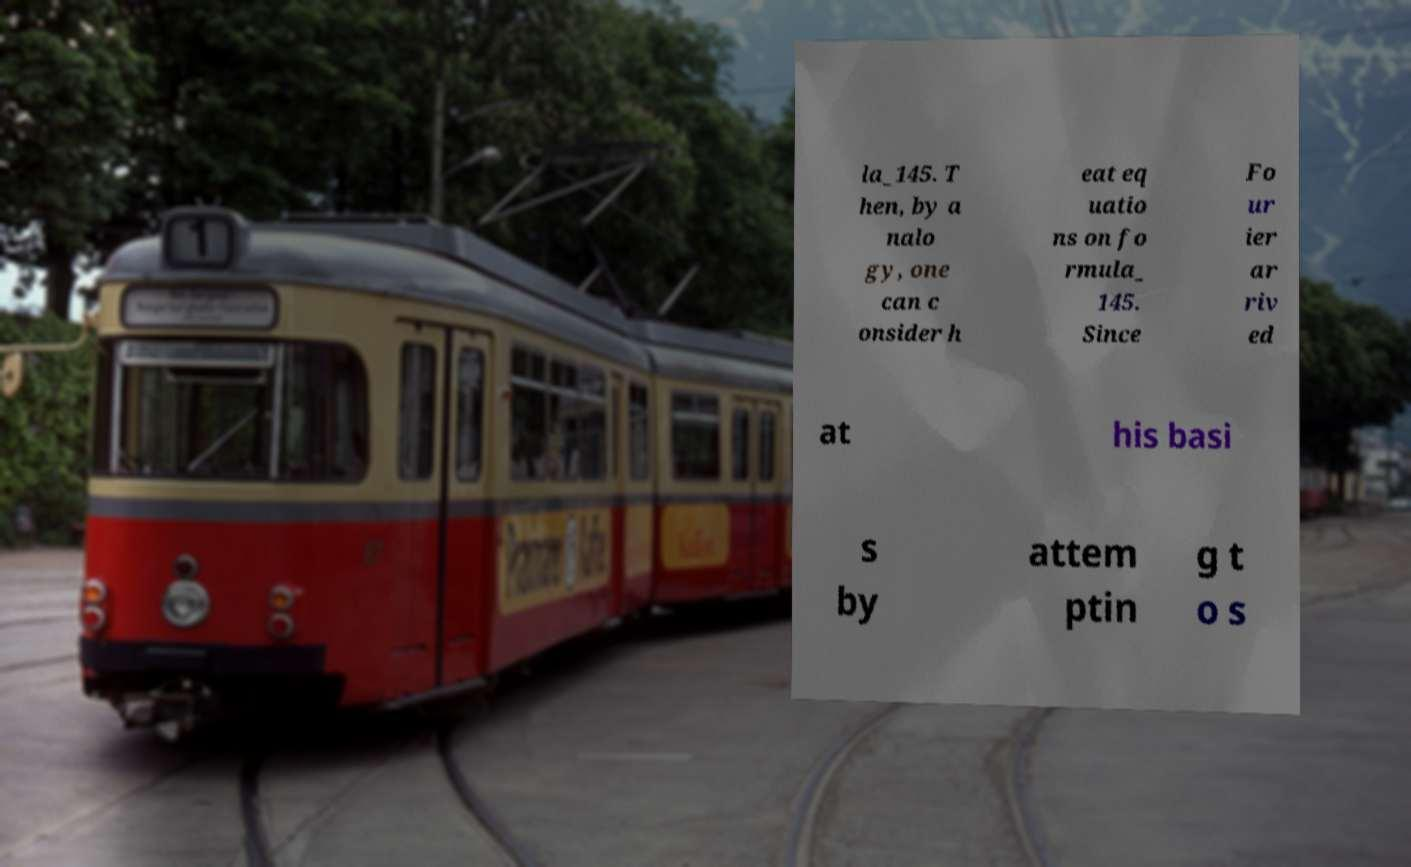For documentation purposes, I need the text within this image transcribed. Could you provide that? la_145. T hen, by a nalo gy, one can c onsider h eat eq uatio ns on fo rmula_ 145. Since Fo ur ier ar riv ed at his basi s by attem ptin g t o s 